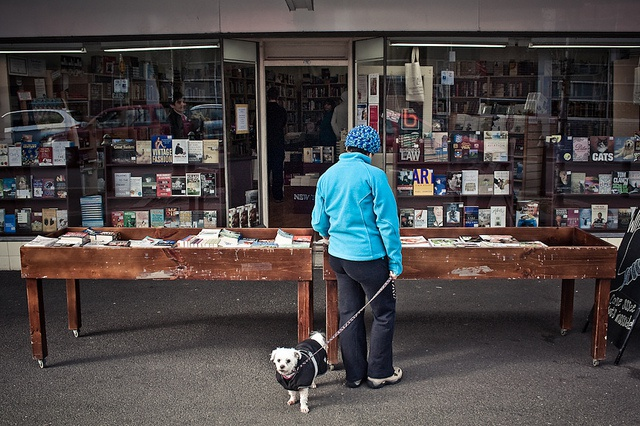Describe the objects in this image and their specific colors. I can see book in black, gray, darkgray, and maroon tones, people in black and lightblue tones, car in black and gray tones, dog in black, white, gray, and darkgray tones, and car in black, gray, and darkgray tones in this image. 